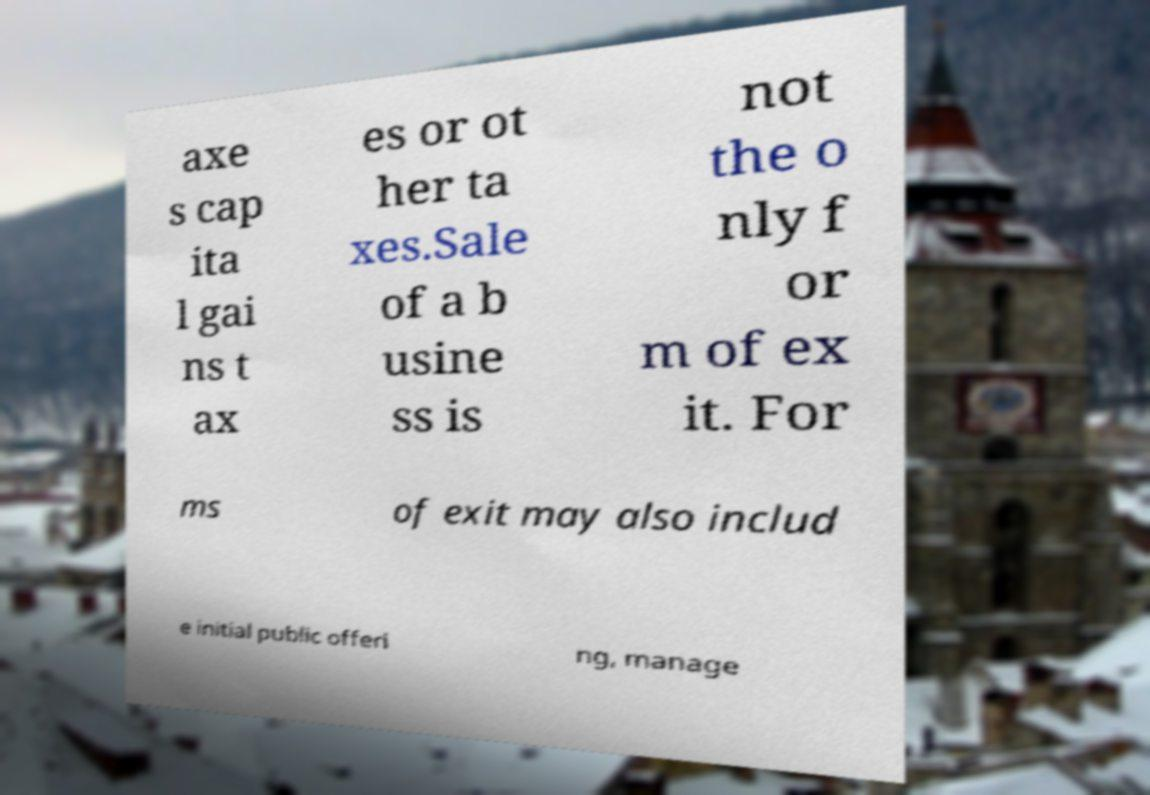What messages or text are displayed in this image? I need them in a readable, typed format. axe s cap ita l gai ns t ax es or ot her ta xes.Sale of a b usine ss is not the o nly f or m of ex it. For ms of exit may also includ e initial public offeri ng, manage 